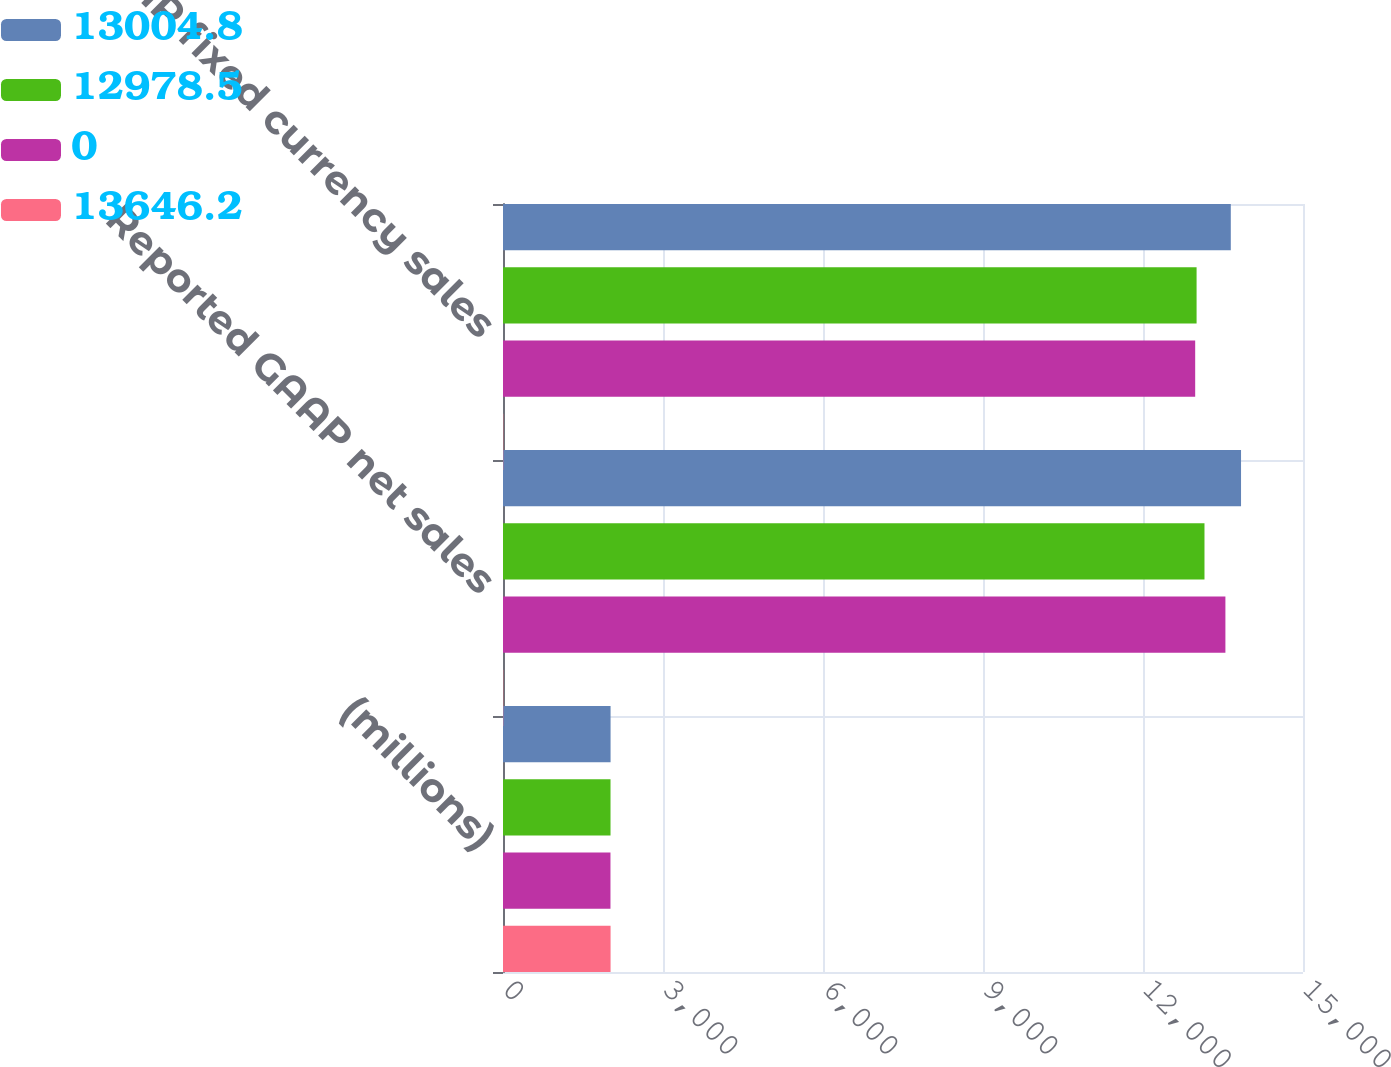Convert chart to OTSL. <chart><loc_0><loc_0><loc_500><loc_500><stacked_bar_chart><ecel><fcel>(millions)<fcel>Reported GAAP net sales<fcel>Non-GAAP fixed currency sales<nl><fcel>13004.8<fcel>2017<fcel>13838.3<fcel>13646.2<nl><fcel>12978.5<fcel>2016<fcel>13152.8<fcel>13004.8<nl><fcel>0<fcel>2015<fcel>13545.1<fcel>12978.5<nl><fcel>13646.2<fcel>2017<fcel>5<fcel>5<nl></chart> 